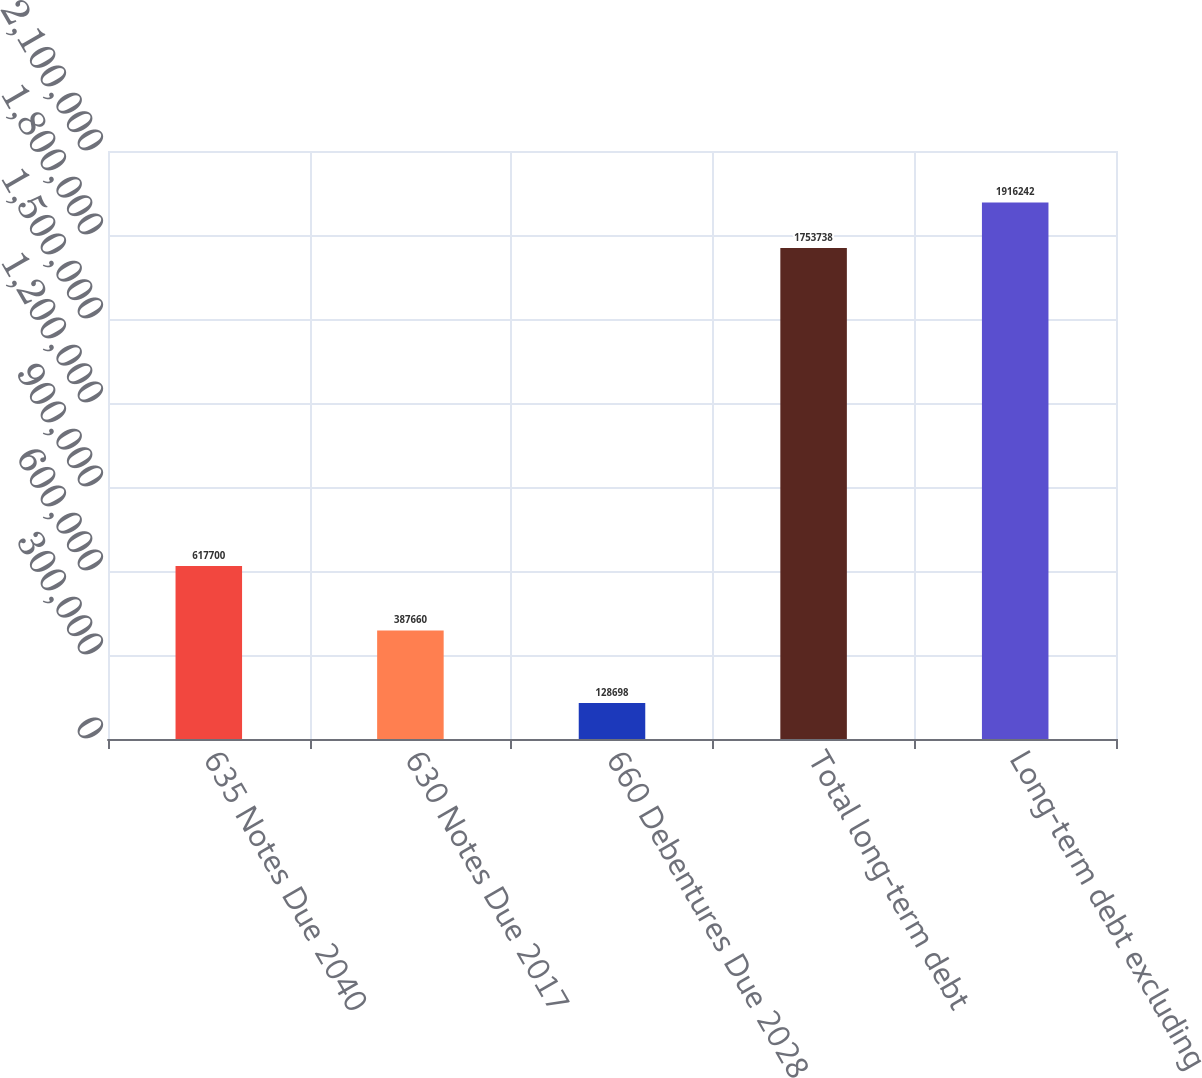<chart> <loc_0><loc_0><loc_500><loc_500><bar_chart><fcel>635 Notes Due 2040<fcel>630 Notes Due 2017<fcel>660 Debentures Due 2028<fcel>Total long-term debt<fcel>Long-term debt excluding<nl><fcel>617700<fcel>387660<fcel>128698<fcel>1.75374e+06<fcel>1.91624e+06<nl></chart> 